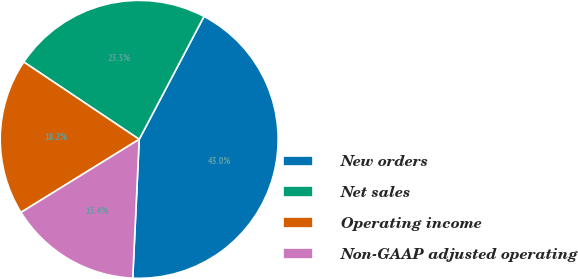<chart> <loc_0><loc_0><loc_500><loc_500><pie_chart><fcel>New orders<fcel>Net sales<fcel>Operating income<fcel>Non-GAAP adjusted operating<nl><fcel>43.02%<fcel>23.33%<fcel>18.21%<fcel>15.45%<nl></chart> 